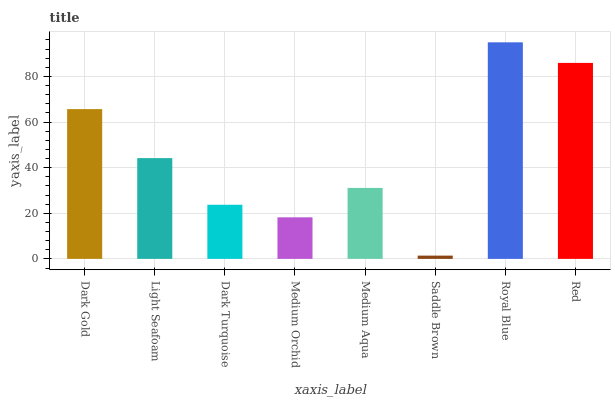Is Saddle Brown the minimum?
Answer yes or no. Yes. Is Royal Blue the maximum?
Answer yes or no. Yes. Is Light Seafoam the minimum?
Answer yes or no. No. Is Light Seafoam the maximum?
Answer yes or no. No. Is Dark Gold greater than Light Seafoam?
Answer yes or no. Yes. Is Light Seafoam less than Dark Gold?
Answer yes or no. Yes. Is Light Seafoam greater than Dark Gold?
Answer yes or no. No. Is Dark Gold less than Light Seafoam?
Answer yes or no. No. Is Light Seafoam the high median?
Answer yes or no. Yes. Is Medium Aqua the low median?
Answer yes or no. Yes. Is Medium Orchid the high median?
Answer yes or no. No. Is Saddle Brown the low median?
Answer yes or no. No. 